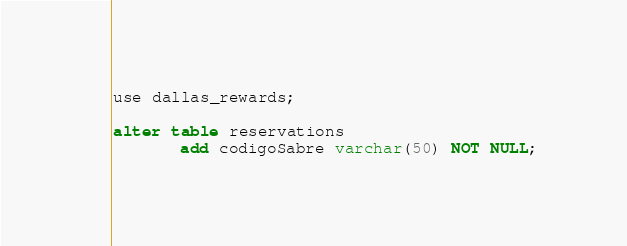<code> <loc_0><loc_0><loc_500><loc_500><_SQL_>use dallas_rewards;

alter table reservations
       add codigoSabre varchar(50) NOT NULL;
</code> 